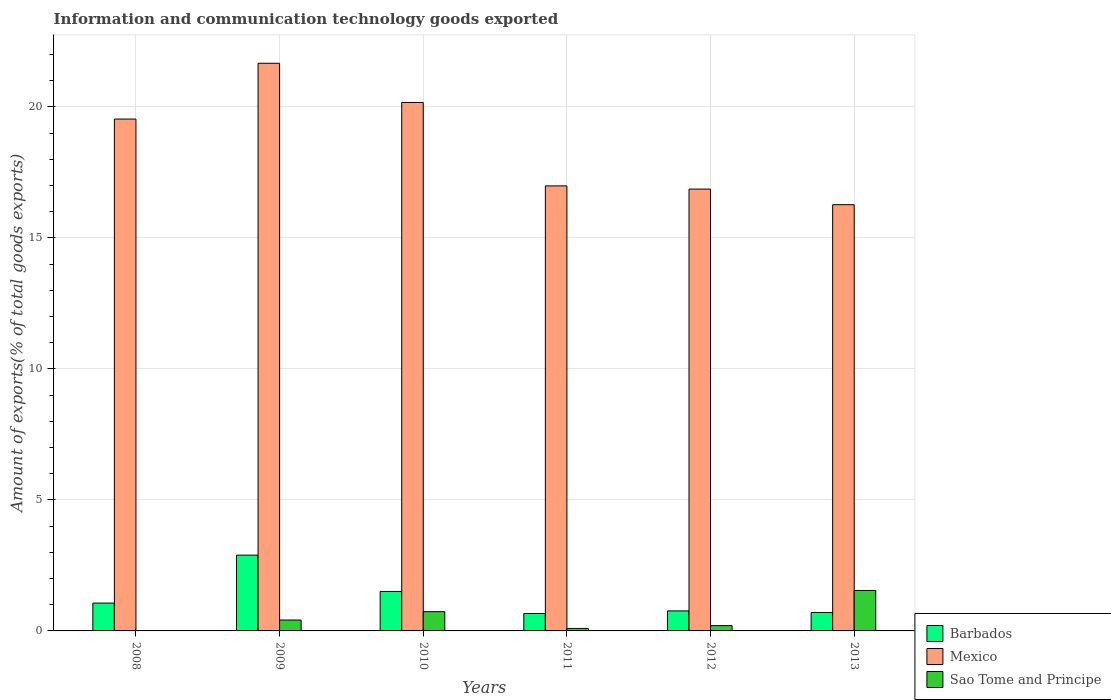How many different coloured bars are there?
Your answer should be compact. 3. How many groups of bars are there?
Make the answer very short. 6. Are the number of bars per tick equal to the number of legend labels?
Ensure brevity in your answer.  Yes. Are the number of bars on each tick of the X-axis equal?
Ensure brevity in your answer.  Yes. What is the amount of goods exported in Sao Tome and Principe in 2011?
Keep it short and to the point. 0.1. Across all years, what is the maximum amount of goods exported in Sao Tome and Principe?
Ensure brevity in your answer.  1.54. Across all years, what is the minimum amount of goods exported in Mexico?
Offer a terse response. 16.27. In which year was the amount of goods exported in Barbados minimum?
Your response must be concise. 2011. What is the total amount of goods exported in Mexico in the graph?
Offer a very short reply. 111.48. What is the difference between the amount of goods exported in Sao Tome and Principe in 2011 and that in 2012?
Offer a very short reply. -0.11. What is the difference between the amount of goods exported in Barbados in 2008 and the amount of goods exported in Mexico in 2011?
Make the answer very short. -15.92. What is the average amount of goods exported in Sao Tome and Principe per year?
Offer a very short reply. 0.5. In the year 2008, what is the difference between the amount of goods exported in Barbados and amount of goods exported in Mexico?
Provide a succinct answer. -18.47. In how many years, is the amount of goods exported in Mexico greater than 11 %?
Provide a succinct answer. 6. What is the ratio of the amount of goods exported in Mexico in 2010 to that in 2011?
Give a very brief answer. 1.19. Is the amount of goods exported in Barbados in 2009 less than that in 2011?
Make the answer very short. No. Is the difference between the amount of goods exported in Barbados in 2010 and 2011 greater than the difference between the amount of goods exported in Mexico in 2010 and 2011?
Provide a short and direct response. No. What is the difference between the highest and the second highest amount of goods exported in Mexico?
Make the answer very short. 1.5. What is the difference between the highest and the lowest amount of goods exported in Barbados?
Provide a short and direct response. 2.23. In how many years, is the amount of goods exported in Mexico greater than the average amount of goods exported in Mexico taken over all years?
Provide a succinct answer. 3. Is the sum of the amount of goods exported in Sao Tome and Principe in 2011 and 2013 greater than the maximum amount of goods exported in Mexico across all years?
Keep it short and to the point. No. What does the 3rd bar from the left in 2012 represents?
Your answer should be very brief. Sao Tome and Principe. What does the 1st bar from the right in 2009 represents?
Offer a very short reply. Sao Tome and Principe. Is it the case that in every year, the sum of the amount of goods exported in Barbados and amount of goods exported in Sao Tome and Principe is greater than the amount of goods exported in Mexico?
Ensure brevity in your answer.  No. Are all the bars in the graph horizontal?
Your response must be concise. No. How many years are there in the graph?
Offer a very short reply. 6. Does the graph contain any zero values?
Offer a very short reply. No. Where does the legend appear in the graph?
Give a very brief answer. Bottom right. How many legend labels are there?
Your answer should be very brief. 3. How are the legend labels stacked?
Offer a terse response. Vertical. What is the title of the graph?
Make the answer very short. Information and communication technology goods exported. Does "Indonesia" appear as one of the legend labels in the graph?
Provide a short and direct response. No. What is the label or title of the Y-axis?
Keep it short and to the point. Amount of exports(% of total goods exports). What is the Amount of exports(% of total goods exports) in Barbados in 2008?
Your response must be concise. 1.06. What is the Amount of exports(% of total goods exports) in Mexico in 2008?
Your response must be concise. 19.53. What is the Amount of exports(% of total goods exports) in Sao Tome and Principe in 2008?
Your answer should be compact. 0.01. What is the Amount of exports(% of total goods exports) of Barbados in 2009?
Give a very brief answer. 2.89. What is the Amount of exports(% of total goods exports) in Mexico in 2009?
Give a very brief answer. 21.66. What is the Amount of exports(% of total goods exports) in Sao Tome and Principe in 2009?
Offer a terse response. 0.42. What is the Amount of exports(% of total goods exports) of Barbados in 2010?
Ensure brevity in your answer.  1.51. What is the Amount of exports(% of total goods exports) in Mexico in 2010?
Ensure brevity in your answer.  20.17. What is the Amount of exports(% of total goods exports) in Sao Tome and Principe in 2010?
Your answer should be very brief. 0.74. What is the Amount of exports(% of total goods exports) in Barbados in 2011?
Keep it short and to the point. 0.66. What is the Amount of exports(% of total goods exports) in Mexico in 2011?
Offer a very short reply. 16.98. What is the Amount of exports(% of total goods exports) in Sao Tome and Principe in 2011?
Provide a short and direct response. 0.1. What is the Amount of exports(% of total goods exports) of Barbados in 2012?
Ensure brevity in your answer.  0.76. What is the Amount of exports(% of total goods exports) of Mexico in 2012?
Your answer should be compact. 16.86. What is the Amount of exports(% of total goods exports) in Sao Tome and Principe in 2012?
Your response must be concise. 0.2. What is the Amount of exports(% of total goods exports) of Barbados in 2013?
Your answer should be compact. 0.7. What is the Amount of exports(% of total goods exports) of Mexico in 2013?
Keep it short and to the point. 16.27. What is the Amount of exports(% of total goods exports) in Sao Tome and Principe in 2013?
Make the answer very short. 1.54. Across all years, what is the maximum Amount of exports(% of total goods exports) in Barbados?
Ensure brevity in your answer.  2.89. Across all years, what is the maximum Amount of exports(% of total goods exports) in Mexico?
Offer a very short reply. 21.66. Across all years, what is the maximum Amount of exports(% of total goods exports) in Sao Tome and Principe?
Offer a very short reply. 1.54. Across all years, what is the minimum Amount of exports(% of total goods exports) in Barbados?
Your response must be concise. 0.66. Across all years, what is the minimum Amount of exports(% of total goods exports) of Mexico?
Make the answer very short. 16.27. Across all years, what is the minimum Amount of exports(% of total goods exports) of Sao Tome and Principe?
Your answer should be compact. 0.01. What is the total Amount of exports(% of total goods exports) in Barbados in the graph?
Ensure brevity in your answer.  7.59. What is the total Amount of exports(% of total goods exports) in Mexico in the graph?
Provide a short and direct response. 111.48. What is the total Amount of exports(% of total goods exports) in Sao Tome and Principe in the graph?
Ensure brevity in your answer.  3. What is the difference between the Amount of exports(% of total goods exports) of Barbados in 2008 and that in 2009?
Keep it short and to the point. -1.83. What is the difference between the Amount of exports(% of total goods exports) of Mexico in 2008 and that in 2009?
Offer a terse response. -2.13. What is the difference between the Amount of exports(% of total goods exports) in Sao Tome and Principe in 2008 and that in 2009?
Make the answer very short. -0.41. What is the difference between the Amount of exports(% of total goods exports) in Barbados in 2008 and that in 2010?
Ensure brevity in your answer.  -0.44. What is the difference between the Amount of exports(% of total goods exports) in Mexico in 2008 and that in 2010?
Keep it short and to the point. -0.63. What is the difference between the Amount of exports(% of total goods exports) of Sao Tome and Principe in 2008 and that in 2010?
Offer a terse response. -0.73. What is the difference between the Amount of exports(% of total goods exports) of Barbados in 2008 and that in 2011?
Offer a very short reply. 0.4. What is the difference between the Amount of exports(% of total goods exports) in Mexico in 2008 and that in 2011?
Your answer should be compact. 2.55. What is the difference between the Amount of exports(% of total goods exports) in Sao Tome and Principe in 2008 and that in 2011?
Offer a terse response. -0.09. What is the difference between the Amount of exports(% of total goods exports) in Barbados in 2008 and that in 2012?
Offer a very short reply. 0.3. What is the difference between the Amount of exports(% of total goods exports) of Mexico in 2008 and that in 2012?
Provide a succinct answer. 2.67. What is the difference between the Amount of exports(% of total goods exports) in Sao Tome and Principe in 2008 and that in 2012?
Offer a very short reply. -0.2. What is the difference between the Amount of exports(% of total goods exports) in Barbados in 2008 and that in 2013?
Offer a very short reply. 0.36. What is the difference between the Amount of exports(% of total goods exports) of Mexico in 2008 and that in 2013?
Keep it short and to the point. 3.27. What is the difference between the Amount of exports(% of total goods exports) of Sao Tome and Principe in 2008 and that in 2013?
Your answer should be compact. -1.54. What is the difference between the Amount of exports(% of total goods exports) of Barbados in 2009 and that in 2010?
Offer a very short reply. 1.39. What is the difference between the Amount of exports(% of total goods exports) of Mexico in 2009 and that in 2010?
Offer a terse response. 1.5. What is the difference between the Amount of exports(% of total goods exports) of Sao Tome and Principe in 2009 and that in 2010?
Your response must be concise. -0.32. What is the difference between the Amount of exports(% of total goods exports) in Barbados in 2009 and that in 2011?
Offer a terse response. 2.23. What is the difference between the Amount of exports(% of total goods exports) of Mexico in 2009 and that in 2011?
Your answer should be compact. 4.68. What is the difference between the Amount of exports(% of total goods exports) in Sao Tome and Principe in 2009 and that in 2011?
Your answer should be compact. 0.32. What is the difference between the Amount of exports(% of total goods exports) in Barbados in 2009 and that in 2012?
Ensure brevity in your answer.  2.13. What is the difference between the Amount of exports(% of total goods exports) in Mexico in 2009 and that in 2012?
Make the answer very short. 4.8. What is the difference between the Amount of exports(% of total goods exports) of Sao Tome and Principe in 2009 and that in 2012?
Ensure brevity in your answer.  0.21. What is the difference between the Amount of exports(% of total goods exports) in Barbados in 2009 and that in 2013?
Offer a very short reply. 2.19. What is the difference between the Amount of exports(% of total goods exports) in Mexico in 2009 and that in 2013?
Ensure brevity in your answer.  5.4. What is the difference between the Amount of exports(% of total goods exports) of Sao Tome and Principe in 2009 and that in 2013?
Provide a short and direct response. -1.13. What is the difference between the Amount of exports(% of total goods exports) of Barbados in 2010 and that in 2011?
Your response must be concise. 0.84. What is the difference between the Amount of exports(% of total goods exports) in Mexico in 2010 and that in 2011?
Your answer should be very brief. 3.18. What is the difference between the Amount of exports(% of total goods exports) in Sao Tome and Principe in 2010 and that in 2011?
Ensure brevity in your answer.  0.64. What is the difference between the Amount of exports(% of total goods exports) of Barbados in 2010 and that in 2012?
Give a very brief answer. 0.74. What is the difference between the Amount of exports(% of total goods exports) in Mexico in 2010 and that in 2012?
Provide a short and direct response. 3.31. What is the difference between the Amount of exports(% of total goods exports) in Sao Tome and Principe in 2010 and that in 2012?
Your answer should be compact. 0.53. What is the difference between the Amount of exports(% of total goods exports) in Barbados in 2010 and that in 2013?
Your answer should be compact. 0.8. What is the difference between the Amount of exports(% of total goods exports) in Mexico in 2010 and that in 2013?
Keep it short and to the point. 3.9. What is the difference between the Amount of exports(% of total goods exports) in Sao Tome and Principe in 2010 and that in 2013?
Provide a succinct answer. -0.81. What is the difference between the Amount of exports(% of total goods exports) in Barbados in 2011 and that in 2012?
Keep it short and to the point. -0.1. What is the difference between the Amount of exports(% of total goods exports) of Mexico in 2011 and that in 2012?
Offer a very short reply. 0.12. What is the difference between the Amount of exports(% of total goods exports) of Sao Tome and Principe in 2011 and that in 2012?
Your response must be concise. -0.11. What is the difference between the Amount of exports(% of total goods exports) in Barbados in 2011 and that in 2013?
Your answer should be very brief. -0.04. What is the difference between the Amount of exports(% of total goods exports) of Mexico in 2011 and that in 2013?
Offer a very short reply. 0.72. What is the difference between the Amount of exports(% of total goods exports) in Sao Tome and Principe in 2011 and that in 2013?
Offer a very short reply. -1.45. What is the difference between the Amount of exports(% of total goods exports) in Barbados in 2012 and that in 2013?
Ensure brevity in your answer.  0.06. What is the difference between the Amount of exports(% of total goods exports) of Mexico in 2012 and that in 2013?
Your answer should be compact. 0.6. What is the difference between the Amount of exports(% of total goods exports) of Sao Tome and Principe in 2012 and that in 2013?
Make the answer very short. -1.34. What is the difference between the Amount of exports(% of total goods exports) in Barbados in 2008 and the Amount of exports(% of total goods exports) in Mexico in 2009?
Your answer should be very brief. -20.6. What is the difference between the Amount of exports(% of total goods exports) in Barbados in 2008 and the Amount of exports(% of total goods exports) in Sao Tome and Principe in 2009?
Your answer should be very brief. 0.65. What is the difference between the Amount of exports(% of total goods exports) of Mexico in 2008 and the Amount of exports(% of total goods exports) of Sao Tome and Principe in 2009?
Make the answer very short. 19.12. What is the difference between the Amount of exports(% of total goods exports) in Barbados in 2008 and the Amount of exports(% of total goods exports) in Mexico in 2010?
Give a very brief answer. -19.1. What is the difference between the Amount of exports(% of total goods exports) of Barbados in 2008 and the Amount of exports(% of total goods exports) of Sao Tome and Principe in 2010?
Your response must be concise. 0.33. What is the difference between the Amount of exports(% of total goods exports) of Mexico in 2008 and the Amount of exports(% of total goods exports) of Sao Tome and Principe in 2010?
Offer a terse response. 18.8. What is the difference between the Amount of exports(% of total goods exports) of Barbados in 2008 and the Amount of exports(% of total goods exports) of Mexico in 2011?
Your answer should be very brief. -15.92. What is the difference between the Amount of exports(% of total goods exports) in Barbados in 2008 and the Amount of exports(% of total goods exports) in Sao Tome and Principe in 2011?
Ensure brevity in your answer.  0.97. What is the difference between the Amount of exports(% of total goods exports) of Mexico in 2008 and the Amount of exports(% of total goods exports) of Sao Tome and Principe in 2011?
Make the answer very short. 19.44. What is the difference between the Amount of exports(% of total goods exports) of Barbados in 2008 and the Amount of exports(% of total goods exports) of Mexico in 2012?
Your answer should be very brief. -15.8. What is the difference between the Amount of exports(% of total goods exports) of Barbados in 2008 and the Amount of exports(% of total goods exports) of Sao Tome and Principe in 2012?
Ensure brevity in your answer.  0.86. What is the difference between the Amount of exports(% of total goods exports) of Mexico in 2008 and the Amount of exports(% of total goods exports) of Sao Tome and Principe in 2012?
Make the answer very short. 19.33. What is the difference between the Amount of exports(% of total goods exports) of Barbados in 2008 and the Amount of exports(% of total goods exports) of Mexico in 2013?
Your answer should be very brief. -15.2. What is the difference between the Amount of exports(% of total goods exports) in Barbados in 2008 and the Amount of exports(% of total goods exports) in Sao Tome and Principe in 2013?
Provide a succinct answer. -0.48. What is the difference between the Amount of exports(% of total goods exports) in Mexico in 2008 and the Amount of exports(% of total goods exports) in Sao Tome and Principe in 2013?
Your response must be concise. 17.99. What is the difference between the Amount of exports(% of total goods exports) in Barbados in 2009 and the Amount of exports(% of total goods exports) in Mexico in 2010?
Your answer should be compact. -17.27. What is the difference between the Amount of exports(% of total goods exports) of Barbados in 2009 and the Amount of exports(% of total goods exports) of Sao Tome and Principe in 2010?
Provide a succinct answer. 2.16. What is the difference between the Amount of exports(% of total goods exports) in Mexico in 2009 and the Amount of exports(% of total goods exports) in Sao Tome and Principe in 2010?
Your answer should be very brief. 20.93. What is the difference between the Amount of exports(% of total goods exports) in Barbados in 2009 and the Amount of exports(% of total goods exports) in Mexico in 2011?
Make the answer very short. -14.09. What is the difference between the Amount of exports(% of total goods exports) of Barbados in 2009 and the Amount of exports(% of total goods exports) of Sao Tome and Principe in 2011?
Your response must be concise. 2.8. What is the difference between the Amount of exports(% of total goods exports) of Mexico in 2009 and the Amount of exports(% of total goods exports) of Sao Tome and Principe in 2011?
Offer a terse response. 21.57. What is the difference between the Amount of exports(% of total goods exports) in Barbados in 2009 and the Amount of exports(% of total goods exports) in Mexico in 2012?
Provide a short and direct response. -13.97. What is the difference between the Amount of exports(% of total goods exports) in Barbados in 2009 and the Amount of exports(% of total goods exports) in Sao Tome and Principe in 2012?
Your answer should be compact. 2.69. What is the difference between the Amount of exports(% of total goods exports) in Mexico in 2009 and the Amount of exports(% of total goods exports) in Sao Tome and Principe in 2012?
Make the answer very short. 21.46. What is the difference between the Amount of exports(% of total goods exports) in Barbados in 2009 and the Amount of exports(% of total goods exports) in Mexico in 2013?
Offer a very short reply. -13.37. What is the difference between the Amount of exports(% of total goods exports) of Barbados in 2009 and the Amount of exports(% of total goods exports) of Sao Tome and Principe in 2013?
Offer a terse response. 1.35. What is the difference between the Amount of exports(% of total goods exports) in Mexico in 2009 and the Amount of exports(% of total goods exports) in Sao Tome and Principe in 2013?
Provide a succinct answer. 20.12. What is the difference between the Amount of exports(% of total goods exports) of Barbados in 2010 and the Amount of exports(% of total goods exports) of Mexico in 2011?
Provide a succinct answer. -15.48. What is the difference between the Amount of exports(% of total goods exports) of Barbados in 2010 and the Amount of exports(% of total goods exports) of Sao Tome and Principe in 2011?
Offer a very short reply. 1.41. What is the difference between the Amount of exports(% of total goods exports) of Mexico in 2010 and the Amount of exports(% of total goods exports) of Sao Tome and Principe in 2011?
Your answer should be very brief. 20.07. What is the difference between the Amount of exports(% of total goods exports) in Barbados in 2010 and the Amount of exports(% of total goods exports) in Mexico in 2012?
Your answer should be compact. -15.36. What is the difference between the Amount of exports(% of total goods exports) in Barbados in 2010 and the Amount of exports(% of total goods exports) in Sao Tome and Principe in 2012?
Give a very brief answer. 1.3. What is the difference between the Amount of exports(% of total goods exports) in Mexico in 2010 and the Amount of exports(% of total goods exports) in Sao Tome and Principe in 2012?
Your answer should be very brief. 19.96. What is the difference between the Amount of exports(% of total goods exports) in Barbados in 2010 and the Amount of exports(% of total goods exports) in Mexico in 2013?
Give a very brief answer. -14.76. What is the difference between the Amount of exports(% of total goods exports) in Barbados in 2010 and the Amount of exports(% of total goods exports) in Sao Tome and Principe in 2013?
Make the answer very short. -0.04. What is the difference between the Amount of exports(% of total goods exports) in Mexico in 2010 and the Amount of exports(% of total goods exports) in Sao Tome and Principe in 2013?
Your answer should be compact. 18.62. What is the difference between the Amount of exports(% of total goods exports) in Barbados in 2011 and the Amount of exports(% of total goods exports) in Mexico in 2012?
Your answer should be very brief. -16.2. What is the difference between the Amount of exports(% of total goods exports) in Barbados in 2011 and the Amount of exports(% of total goods exports) in Sao Tome and Principe in 2012?
Your response must be concise. 0.46. What is the difference between the Amount of exports(% of total goods exports) in Mexico in 2011 and the Amount of exports(% of total goods exports) in Sao Tome and Principe in 2012?
Keep it short and to the point. 16.78. What is the difference between the Amount of exports(% of total goods exports) of Barbados in 2011 and the Amount of exports(% of total goods exports) of Mexico in 2013?
Your answer should be very brief. -15.6. What is the difference between the Amount of exports(% of total goods exports) of Barbados in 2011 and the Amount of exports(% of total goods exports) of Sao Tome and Principe in 2013?
Your answer should be very brief. -0.88. What is the difference between the Amount of exports(% of total goods exports) in Mexico in 2011 and the Amount of exports(% of total goods exports) in Sao Tome and Principe in 2013?
Give a very brief answer. 15.44. What is the difference between the Amount of exports(% of total goods exports) of Barbados in 2012 and the Amount of exports(% of total goods exports) of Mexico in 2013?
Your answer should be compact. -15.5. What is the difference between the Amount of exports(% of total goods exports) in Barbados in 2012 and the Amount of exports(% of total goods exports) in Sao Tome and Principe in 2013?
Ensure brevity in your answer.  -0.78. What is the difference between the Amount of exports(% of total goods exports) in Mexico in 2012 and the Amount of exports(% of total goods exports) in Sao Tome and Principe in 2013?
Keep it short and to the point. 15.32. What is the average Amount of exports(% of total goods exports) of Barbados per year?
Your answer should be very brief. 1.27. What is the average Amount of exports(% of total goods exports) of Mexico per year?
Offer a terse response. 18.58. What is the average Amount of exports(% of total goods exports) in Sao Tome and Principe per year?
Offer a terse response. 0.5. In the year 2008, what is the difference between the Amount of exports(% of total goods exports) of Barbados and Amount of exports(% of total goods exports) of Mexico?
Provide a short and direct response. -18.47. In the year 2008, what is the difference between the Amount of exports(% of total goods exports) in Barbados and Amount of exports(% of total goods exports) in Sao Tome and Principe?
Make the answer very short. 1.06. In the year 2008, what is the difference between the Amount of exports(% of total goods exports) in Mexico and Amount of exports(% of total goods exports) in Sao Tome and Principe?
Provide a short and direct response. 19.53. In the year 2009, what is the difference between the Amount of exports(% of total goods exports) of Barbados and Amount of exports(% of total goods exports) of Mexico?
Give a very brief answer. -18.77. In the year 2009, what is the difference between the Amount of exports(% of total goods exports) of Barbados and Amount of exports(% of total goods exports) of Sao Tome and Principe?
Provide a succinct answer. 2.48. In the year 2009, what is the difference between the Amount of exports(% of total goods exports) of Mexico and Amount of exports(% of total goods exports) of Sao Tome and Principe?
Your answer should be very brief. 21.25. In the year 2010, what is the difference between the Amount of exports(% of total goods exports) in Barbados and Amount of exports(% of total goods exports) in Mexico?
Your answer should be compact. -18.66. In the year 2010, what is the difference between the Amount of exports(% of total goods exports) of Barbados and Amount of exports(% of total goods exports) of Sao Tome and Principe?
Offer a very short reply. 0.77. In the year 2010, what is the difference between the Amount of exports(% of total goods exports) in Mexico and Amount of exports(% of total goods exports) in Sao Tome and Principe?
Offer a terse response. 19.43. In the year 2011, what is the difference between the Amount of exports(% of total goods exports) of Barbados and Amount of exports(% of total goods exports) of Mexico?
Offer a terse response. -16.32. In the year 2011, what is the difference between the Amount of exports(% of total goods exports) of Barbados and Amount of exports(% of total goods exports) of Sao Tome and Principe?
Your response must be concise. 0.57. In the year 2011, what is the difference between the Amount of exports(% of total goods exports) in Mexico and Amount of exports(% of total goods exports) in Sao Tome and Principe?
Your answer should be very brief. 16.89. In the year 2012, what is the difference between the Amount of exports(% of total goods exports) in Barbados and Amount of exports(% of total goods exports) in Mexico?
Keep it short and to the point. -16.1. In the year 2012, what is the difference between the Amount of exports(% of total goods exports) in Barbados and Amount of exports(% of total goods exports) in Sao Tome and Principe?
Offer a terse response. 0.56. In the year 2012, what is the difference between the Amount of exports(% of total goods exports) of Mexico and Amount of exports(% of total goods exports) of Sao Tome and Principe?
Offer a very short reply. 16.66. In the year 2013, what is the difference between the Amount of exports(% of total goods exports) of Barbados and Amount of exports(% of total goods exports) of Mexico?
Offer a very short reply. -15.56. In the year 2013, what is the difference between the Amount of exports(% of total goods exports) of Barbados and Amount of exports(% of total goods exports) of Sao Tome and Principe?
Make the answer very short. -0.84. In the year 2013, what is the difference between the Amount of exports(% of total goods exports) in Mexico and Amount of exports(% of total goods exports) in Sao Tome and Principe?
Offer a very short reply. 14.72. What is the ratio of the Amount of exports(% of total goods exports) in Barbados in 2008 to that in 2009?
Make the answer very short. 0.37. What is the ratio of the Amount of exports(% of total goods exports) in Mexico in 2008 to that in 2009?
Your answer should be compact. 0.9. What is the ratio of the Amount of exports(% of total goods exports) of Sao Tome and Principe in 2008 to that in 2009?
Ensure brevity in your answer.  0.01. What is the ratio of the Amount of exports(% of total goods exports) in Barbados in 2008 to that in 2010?
Offer a very short reply. 0.71. What is the ratio of the Amount of exports(% of total goods exports) in Mexico in 2008 to that in 2010?
Offer a terse response. 0.97. What is the ratio of the Amount of exports(% of total goods exports) of Sao Tome and Principe in 2008 to that in 2010?
Ensure brevity in your answer.  0.01. What is the ratio of the Amount of exports(% of total goods exports) in Barbados in 2008 to that in 2011?
Ensure brevity in your answer.  1.6. What is the ratio of the Amount of exports(% of total goods exports) in Mexico in 2008 to that in 2011?
Provide a short and direct response. 1.15. What is the ratio of the Amount of exports(% of total goods exports) in Sao Tome and Principe in 2008 to that in 2011?
Make the answer very short. 0.07. What is the ratio of the Amount of exports(% of total goods exports) in Barbados in 2008 to that in 2012?
Make the answer very short. 1.39. What is the ratio of the Amount of exports(% of total goods exports) in Mexico in 2008 to that in 2012?
Give a very brief answer. 1.16. What is the ratio of the Amount of exports(% of total goods exports) in Sao Tome and Principe in 2008 to that in 2012?
Your answer should be very brief. 0.03. What is the ratio of the Amount of exports(% of total goods exports) in Barbados in 2008 to that in 2013?
Make the answer very short. 1.51. What is the ratio of the Amount of exports(% of total goods exports) of Mexico in 2008 to that in 2013?
Your answer should be very brief. 1.2. What is the ratio of the Amount of exports(% of total goods exports) in Sao Tome and Principe in 2008 to that in 2013?
Keep it short and to the point. 0. What is the ratio of the Amount of exports(% of total goods exports) in Barbados in 2009 to that in 2010?
Offer a very short reply. 1.92. What is the ratio of the Amount of exports(% of total goods exports) of Mexico in 2009 to that in 2010?
Ensure brevity in your answer.  1.07. What is the ratio of the Amount of exports(% of total goods exports) in Sao Tome and Principe in 2009 to that in 2010?
Ensure brevity in your answer.  0.57. What is the ratio of the Amount of exports(% of total goods exports) in Barbados in 2009 to that in 2011?
Provide a short and direct response. 4.35. What is the ratio of the Amount of exports(% of total goods exports) in Mexico in 2009 to that in 2011?
Your response must be concise. 1.28. What is the ratio of the Amount of exports(% of total goods exports) in Sao Tome and Principe in 2009 to that in 2011?
Offer a terse response. 4.37. What is the ratio of the Amount of exports(% of total goods exports) of Barbados in 2009 to that in 2012?
Your answer should be compact. 3.79. What is the ratio of the Amount of exports(% of total goods exports) in Mexico in 2009 to that in 2012?
Ensure brevity in your answer.  1.28. What is the ratio of the Amount of exports(% of total goods exports) in Sao Tome and Principe in 2009 to that in 2012?
Your answer should be very brief. 2.06. What is the ratio of the Amount of exports(% of total goods exports) of Barbados in 2009 to that in 2013?
Offer a very short reply. 4.12. What is the ratio of the Amount of exports(% of total goods exports) in Mexico in 2009 to that in 2013?
Your answer should be very brief. 1.33. What is the ratio of the Amount of exports(% of total goods exports) in Sao Tome and Principe in 2009 to that in 2013?
Offer a very short reply. 0.27. What is the ratio of the Amount of exports(% of total goods exports) in Barbados in 2010 to that in 2011?
Ensure brevity in your answer.  2.27. What is the ratio of the Amount of exports(% of total goods exports) in Mexico in 2010 to that in 2011?
Provide a short and direct response. 1.19. What is the ratio of the Amount of exports(% of total goods exports) in Sao Tome and Principe in 2010 to that in 2011?
Your response must be concise. 7.73. What is the ratio of the Amount of exports(% of total goods exports) in Barbados in 2010 to that in 2012?
Offer a very short reply. 1.97. What is the ratio of the Amount of exports(% of total goods exports) in Mexico in 2010 to that in 2012?
Make the answer very short. 1.2. What is the ratio of the Amount of exports(% of total goods exports) in Sao Tome and Principe in 2010 to that in 2012?
Keep it short and to the point. 3.64. What is the ratio of the Amount of exports(% of total goods exports) of Barbados in 2010 to that in 2013?
Give a very brief answer. 2.14. What is the ratio of the Amount of exports(% of total goods exports) of Mexico in 2010 to that in 2013?
Your answer should be compact. 1.24. What is the ratio of the Amount of exports(% of total goods exports) in Sao Tome and Principe in 2010 to that in 2013?
Your response must be concise. 0.48. What is the ratio of the Amount of exports(% of total goods exports) of Barbados in 2011 to that in 2012?
Offer a terse response. 0.87. What is the ratio of the Amount of exports(% of total goods exports) of Mexico in 2011 to that in 2012?
Keep it short and to the point. 1.01. What is the ratio of the Amount of exports(% of total goods exports) in Sao Tome and Principe in 2011 to that in 2012?
Offer a terse response. 0.47. What is the ratio of the Amount of exports(% of total goods exports) of Barbados in 2011 to that in 2013?
Your answer should be compact. 0.95. What is the ratio of the Amount of exports(% of total goods exports) in Mexico in 2011 to that in 2013?
Your response must be concise. 1.04. What is the ratio of the Amount of exports(% of total goods exports) in Sao Tome and Principe in 2011 to that in 2013?
Provide a succinct answer. 0.06. What is the ratio of the Amount of exports(% of total goods exports) of Barbados in 2012 to that in 2013?
Your response must be concise. 1.09. What is the ratio of the Amount of exports(% of total goods exports) of Mexico in 2012 to that in 2013?
Offer a very short reply. 1.04. What is the ratio of the Amount of exports(% of total goods exports) of Sao Tome and Principe in 2012 to that in 2013?
Ensure brevity in your answer.  0.13. What is the difference between the highest and the second highest Amount of exports(% of total goods exports) in Barbados?
Provide a short and direct response. 1.39. What is the difference between the highest and the second highest Amount of exports(% of total goods exports) in Mexico?
Offer a very short reply. 1.5. What is the difference between the highest and the second highest Amount of exports(% of total goods exports) in Sao Tome and Principe?
Make the answer very short. 0.81. What is the difference between the highest and the lowest Amount of exports(% of total goods exports) of Barbados?
Keep it short and to the point. 2.23. What is the difference between the highest and the lowest Amount of exports(% of total goods exports) of Mexico?
Provide a short and direct response. 5.4. What is the difference between the highest and the lowest Amount of exports(% of total goods exports) in Sao Tome and Principe?
Offer a very short reply. 1.54. 